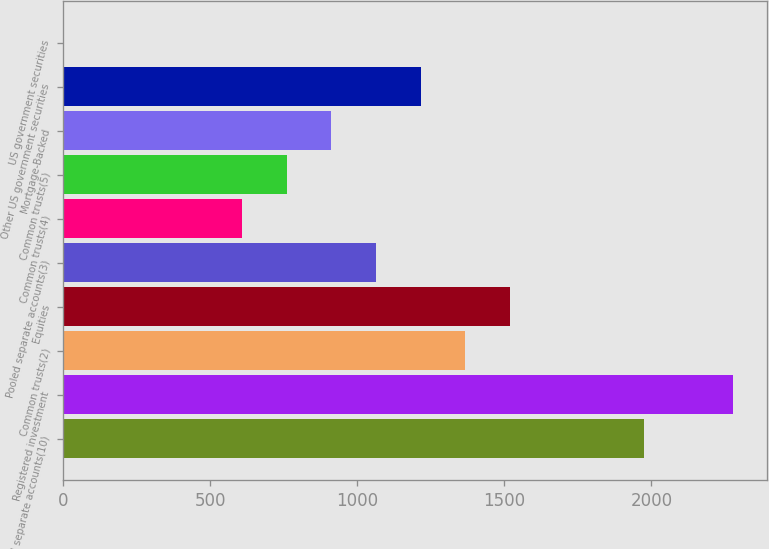Convert chart. <chart><loc_0><loc_0><loc_500><loc_500><bar_chart><fcel>Pooled separate accounts(10)<fcel>Registered investment<fcel>Common trusts(2)<fcel>Equities<fcel>Pooled separate accounts(3)<fcel>Common trusts(4)<fcel>Common trusts(5)<fcel>Mortgage-Backed<fcel>Other US government securities<fcel>US government securities<nl><fcel>1974.4<fcel>2278<fcel>1367.2<fcel>1519<fcel>1063.6<fcel>608.2<fcel>760<fcel>911.8<fcel>1215.4<fcel>1<nl></chart> 